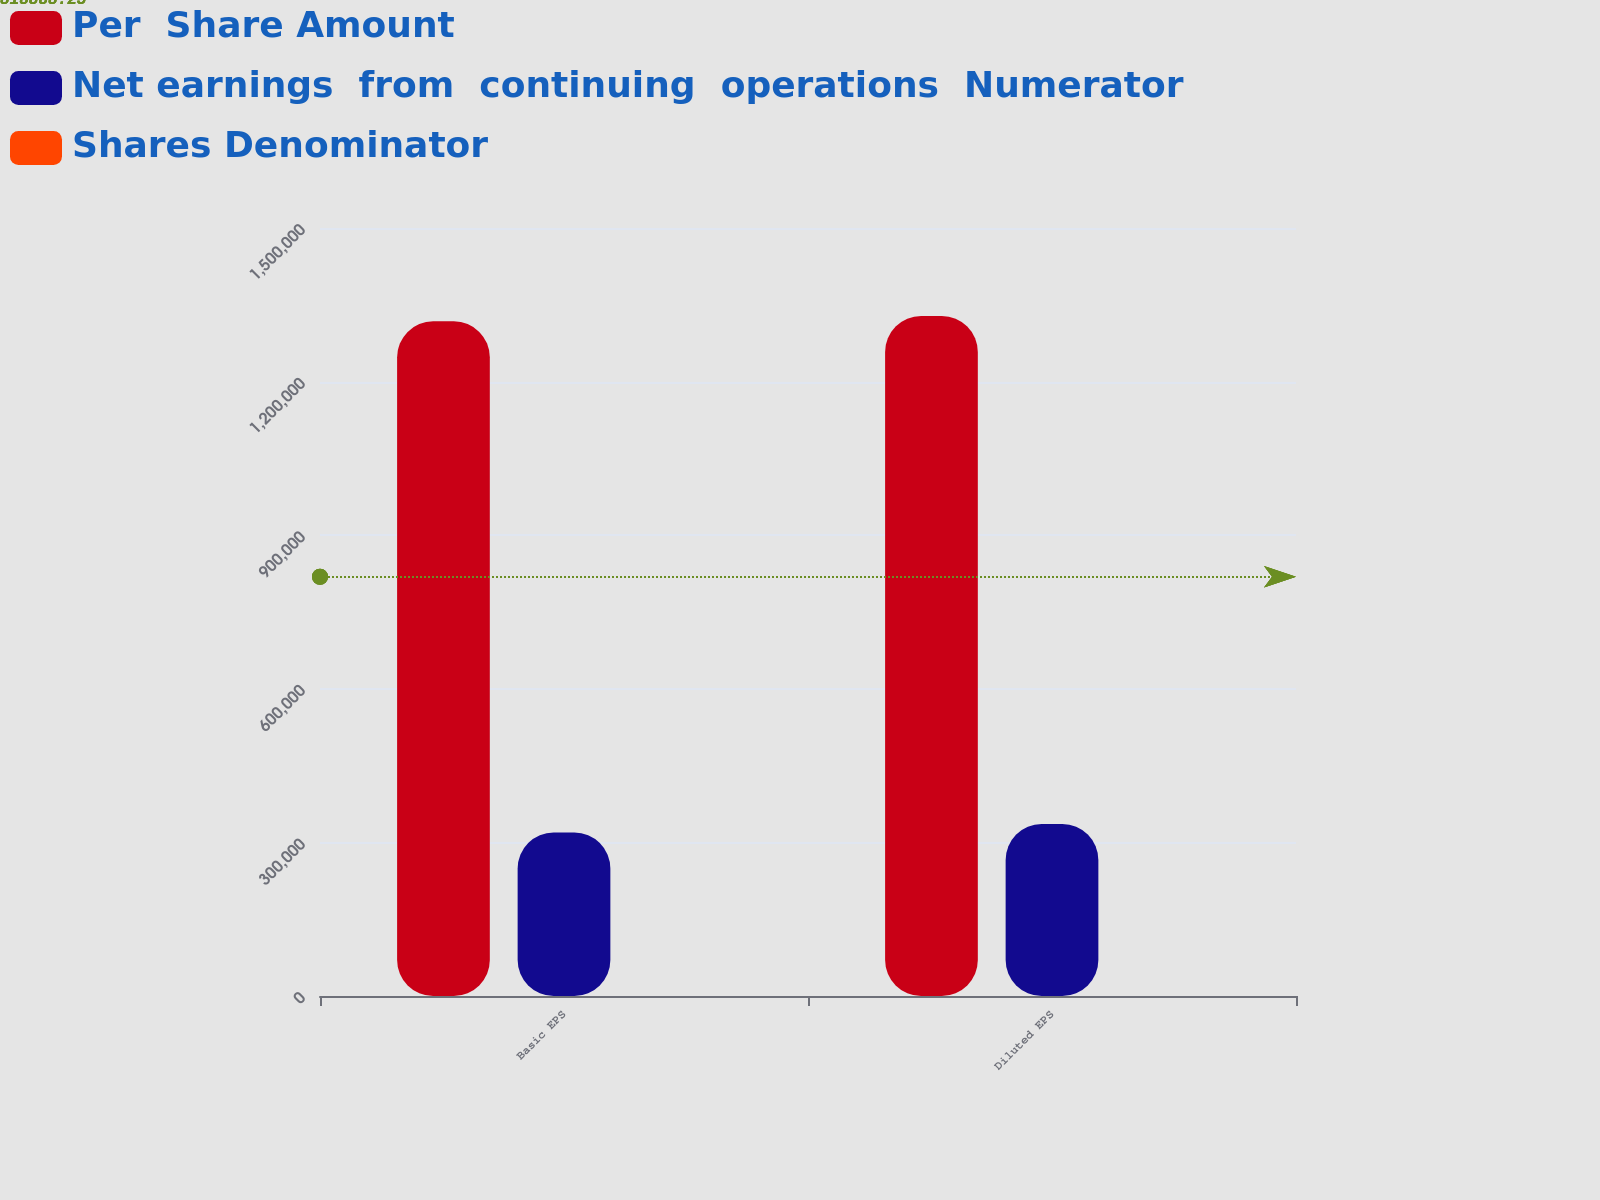<chart> <loc_0><loc_0><loc_500><loc_500><stacked_bar_chart><ecel><fcel>Basic EPS<fcel>Diluted EPS<nl><fcel>Per  Share Amount<fcel>1.31763e+06<fcel>1.328e+06<nl><fcel>Net earnings  from  continuing  operations  Numerator<fcel>319361<fcel>335863<nl><fcel>Shares Denominator<fcel>4.13<fcel>3.95<nl></chart> 